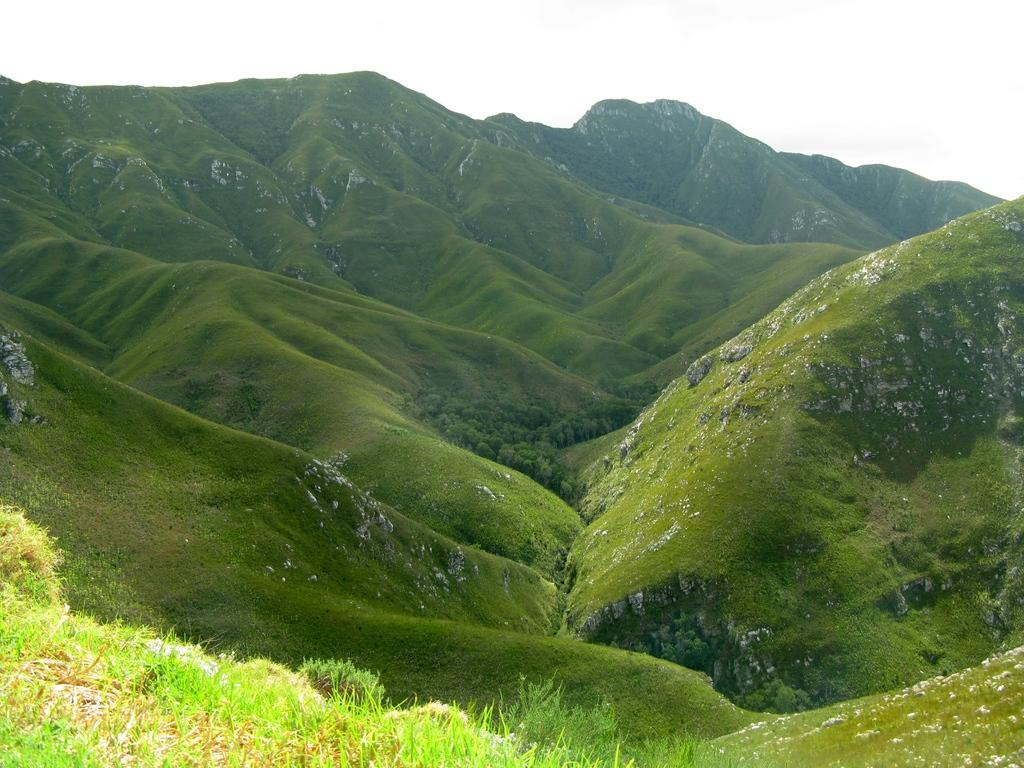Where might the image have been taken? The image might have been taken outside of the city. What type of terrain is visible in the image? There is grass visible in the image, which suggests a grassy area. What other objects can be seen in the image? There are rocks in the image. What is visible at the top of the image? The sky is visible at the top of the image. What type of plot is being used to grow the grass in the image? There is no indication of a plot or any gardening activity in the image; it simply shows grass and rocks. What type of coil is visible in the image? There is no coil present in the image. 